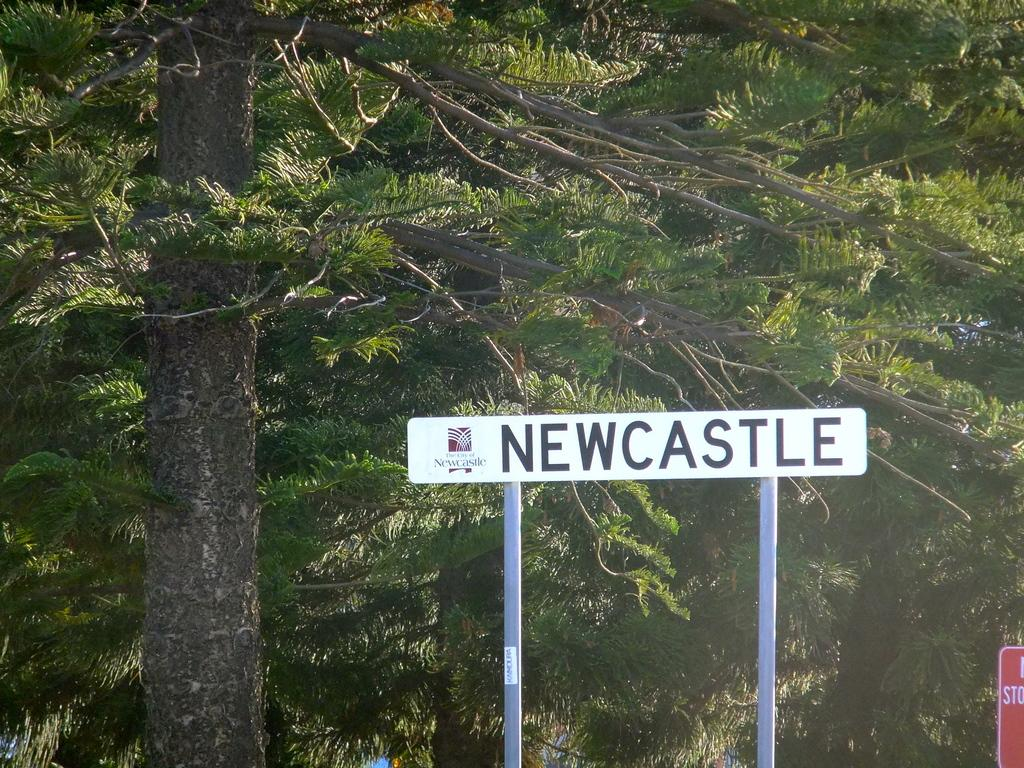What structures can be seen in the image? There are poles in the image. What signage is present in the image? There is a name board in the image. What type of natural environment is visible in the background of the image? There are trees visible in the background of the image. How many rabbits can be seen playing with a net in the image? There are no rabbits or nets present in the image. 